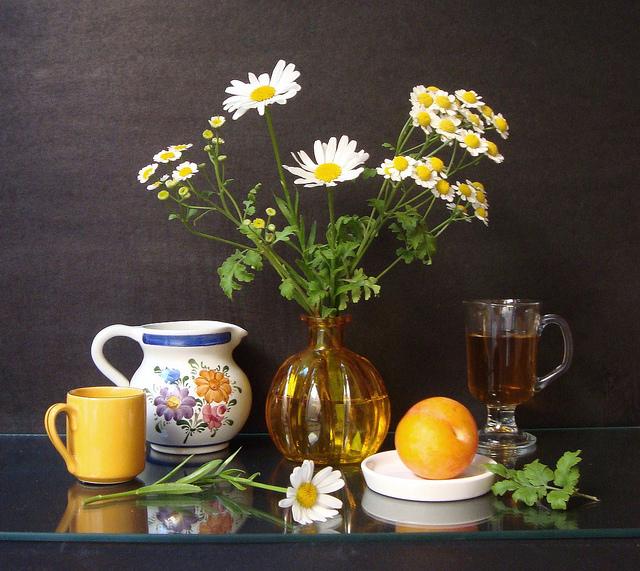Are the flowers wilted?
Short answer required. No. What color is the vase?
Be succinct. Yellow. What type of fruit do you see?
Concise answer only. Orange. 